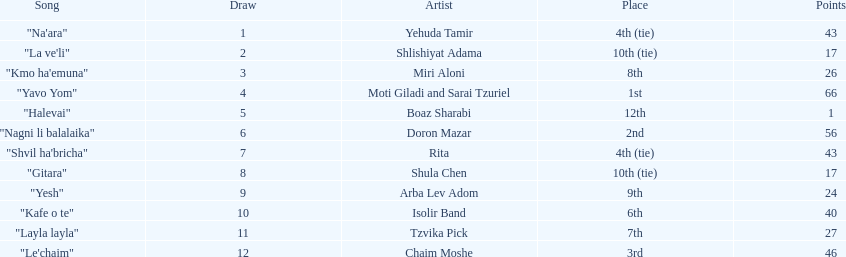Compare draws, which had the least amount of points? Boaz Sharabi. 